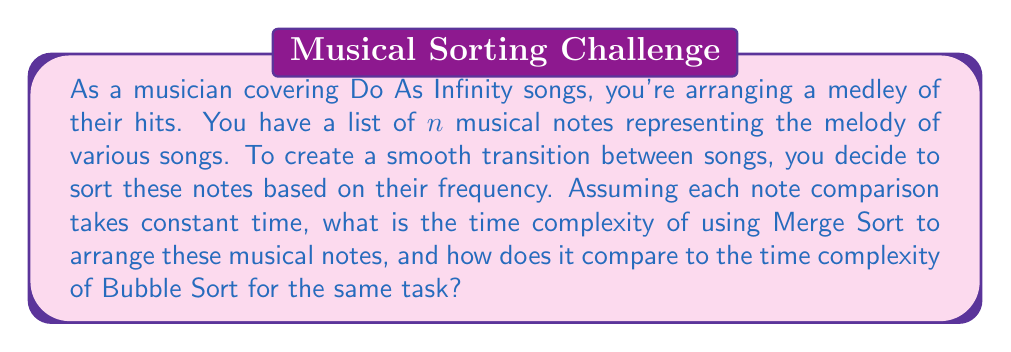Can you answer this question? Let's analyze the time complexity of both Merge Sort and Bubble Sort for arranging $n$ musical notes:

1. Merge Sort:
   Merge Sort follows a divide-and-conquer approach:
   a) It recursively divides the list of notes into two halves until we have single-note sublists.
   b) It then merges these sublists, comparing and sorting the notes as it goes.

   The time complexity of Merge Sort can be expressed as:
   $$T(n) = 2T(n/2) + O(n)$$

   Using the Master Theorem, we can solve this recurrence:
   $$a = 2, b = 2, f(n) = O(n)$$
   $$\log_b a = \log_2 2 = 1$$
   
   Since $f(n) = O(n) = O(n^{\log_b a})$, we fall into case 2 of the Master Theorem.

   Therefore, the time complexity of Merge Sort is:
   $$O(n \log n)$$

2. Bubble Sort:
   Bubble Sort repeatedly steps through the list of notes, compares adjacent elements and swaps them if they're in the wrong order.

   In the worst and average cases:
   - The outer loop runs $n-1$ times
   - The inner loop runs $n-i-1$ times for each $i$ from $0$ to $n-2$

   This gives us:
   $$\sum_{i=0}^{n-2} (n-i-1) = \frac{n(n-1)}{2} = O(n^2)$$

   Therefore, the time complexity of Bubble Sort is:
   $$O(n^2)$$

Comparing the two:
- Merge Sort: $O(n \log n)$
- Bubble Sort: $O(n^2)$

For large values of $n$, Merge Sort is significantly faster than Bubble Sort. As the number of musical notes increases, the difference in performance becomes more pronounced.

To visualize this difference:

[asy]
import graph;
size(200,200);
real f(real x) {return x*log(x)/log(2);}
real g(real x) {return x^2;}
draw(graph(f,1,50),blue,Legend("Merge Sort"));
draw(graph(g,1,50),red,Legend("Bubble Sort"));
xaxis("n",0,50,Arrow);
yaxis("Time",0,2500,Arrow);
legend();
[/asy]

This graph clearly shows how Bubble Sort's time complexity grows much faster than Merge Sort's as the input size increases.
Answer: The time complexity of Merge Sort for arranging $n$ musical notes is $O(n \log n)$, while Bubble Sort's time complexity is $O(n^2)$. Merge Sort is significantly more efficient, especially for larger sets of notes, making it a better choice for arranging a large medley of Do As Infinity songs. 